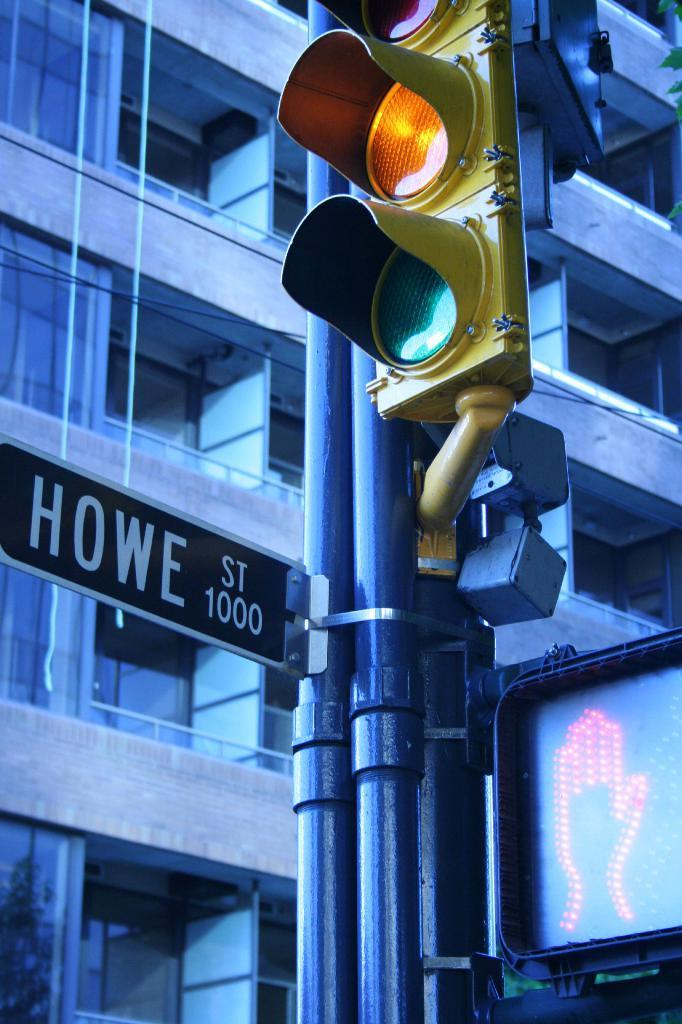<image>
Share a concise interpretation of the image provided. a sign that says the word Howe on it 